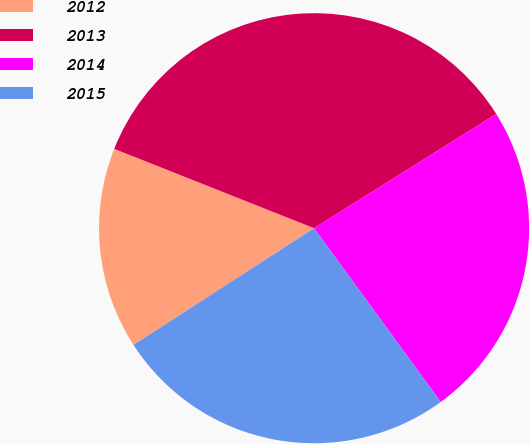Convert chart to OTSL. <chart><loc_0><loc_0><loc_500><loc_500><pie_chart><fcel>2012<fcel>2013<fcel>2014<fcel>2015<nl><fcel>15.15%<fcel>35.07%<fcel>23.89%<fcel>25.89%<nl></chart> 